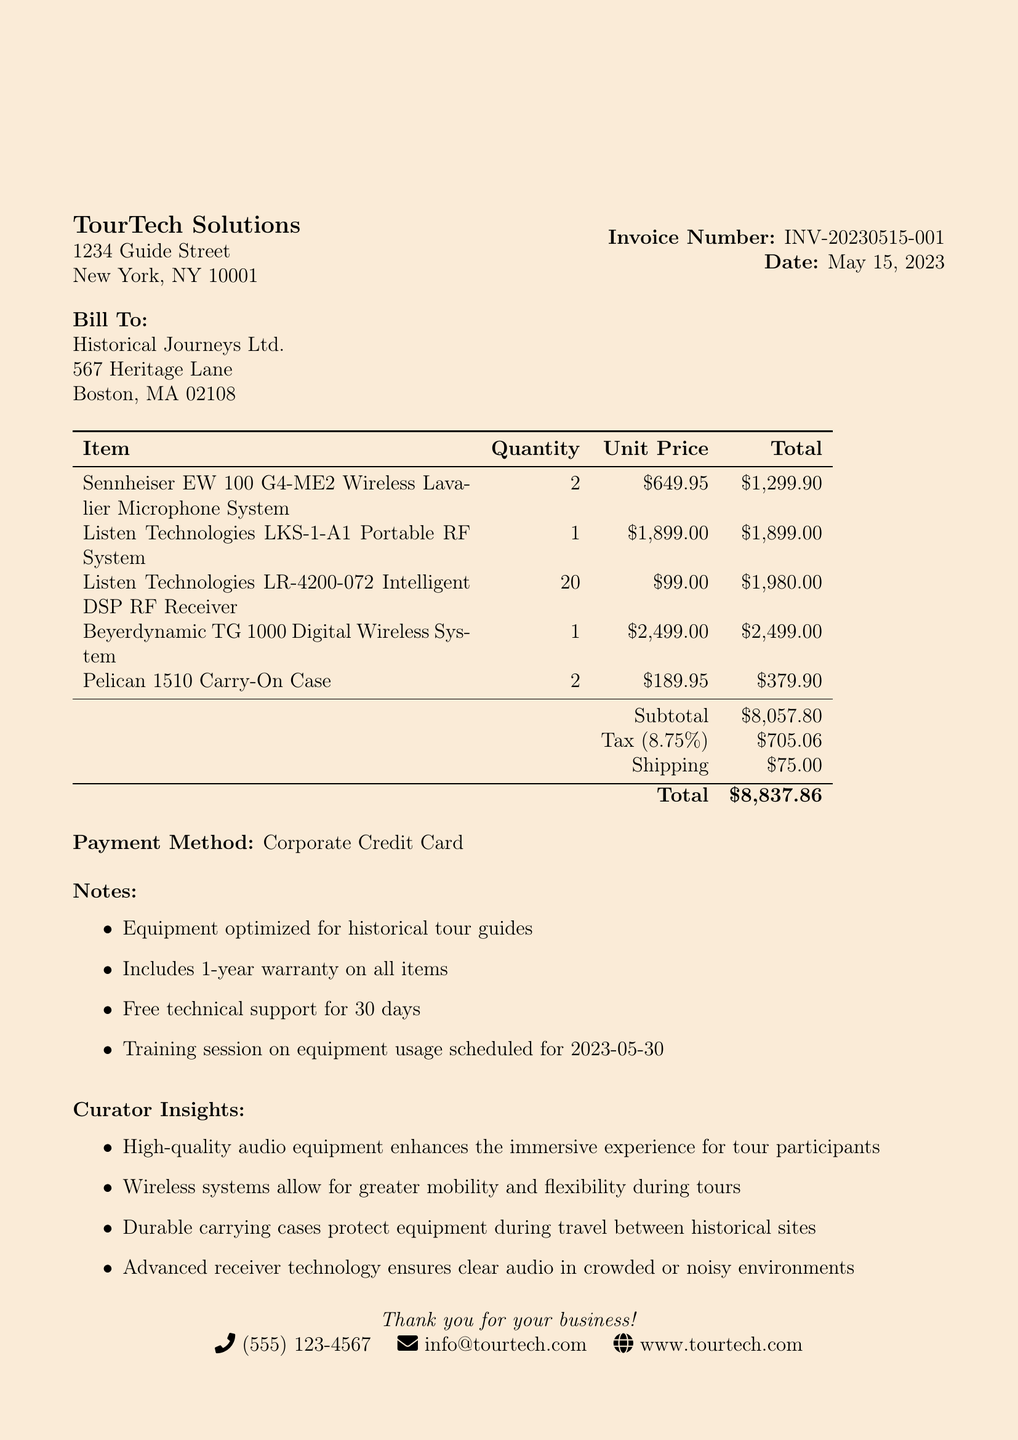What is the vendor name? The vendor name is provided at the top of the document, identifying who the equipment was purchased from.
Answer: TourTech Solutions What is the total amount charged on the receipt? The total amount is calculated by adding the subtotal, tax, and shipping fees listed at the end of the document.
Answer: $8,837.86 What is the date of the transaction? The date is explicitly mentioned on the receipt and indicates when the purchase was made.
Answer: May 15, 2023 How many units of the Beyerdynamic TG 1000 Digital Wireless System were purchased? The quantity of each item purchased is listed in the table section, specifically under the item description.
Answer: 1 What is the tax rate applied to the purchase? The tax rate is mentioned alongside the tax amount to clarify how much tax was calculated on the subtotal.
Answer: 8.75% What is included in the notes about the equipment? The notes section lists specific information about warranties, support, and training relevant to the purchase.
Answer: Equipment optimized for historical tour guides What is the quantity of Listen Technologies LR-4200-072 Intelligent DSP RF Receivers purchased? The number of each type of equipment is listed in the document, and this item has a specified quantity.
Answer: 20 What payment method was used for this purchase? The payment method is specified towards the bottom of the document, indicating how the transaction was completed.
Answer: Corporate Credit Card What insights does the curator provide? The curator insights section highlights important perspectives on the equipment's effectiveness for historical tours.
Answer: High-quality audio equipment enhances the immersive experience for tour participants 